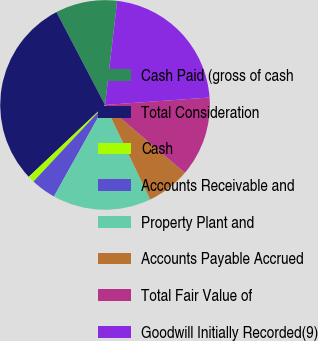Convert chart. <chart><loc_0><loc_0><loc_500><loc_500><pie_chart><fcel>Cash Paid (gross of cash<fcel>Total Consideration<fcel>Cash<fcel>Accounts Receivable and<fcel>Property Plant and<fcel>Accounts Payable Accrued<fcel>Total Fair Value of<fcel>Goodwill Initially Recorded(9)<nl><fcel>9.52%<fcel>29.35%<fcel>1.02%<fcel>3.86%<fcel>15.19%<fcel>6.69%<fcel>12.35%<fcel>22.02%<nl></chart> 